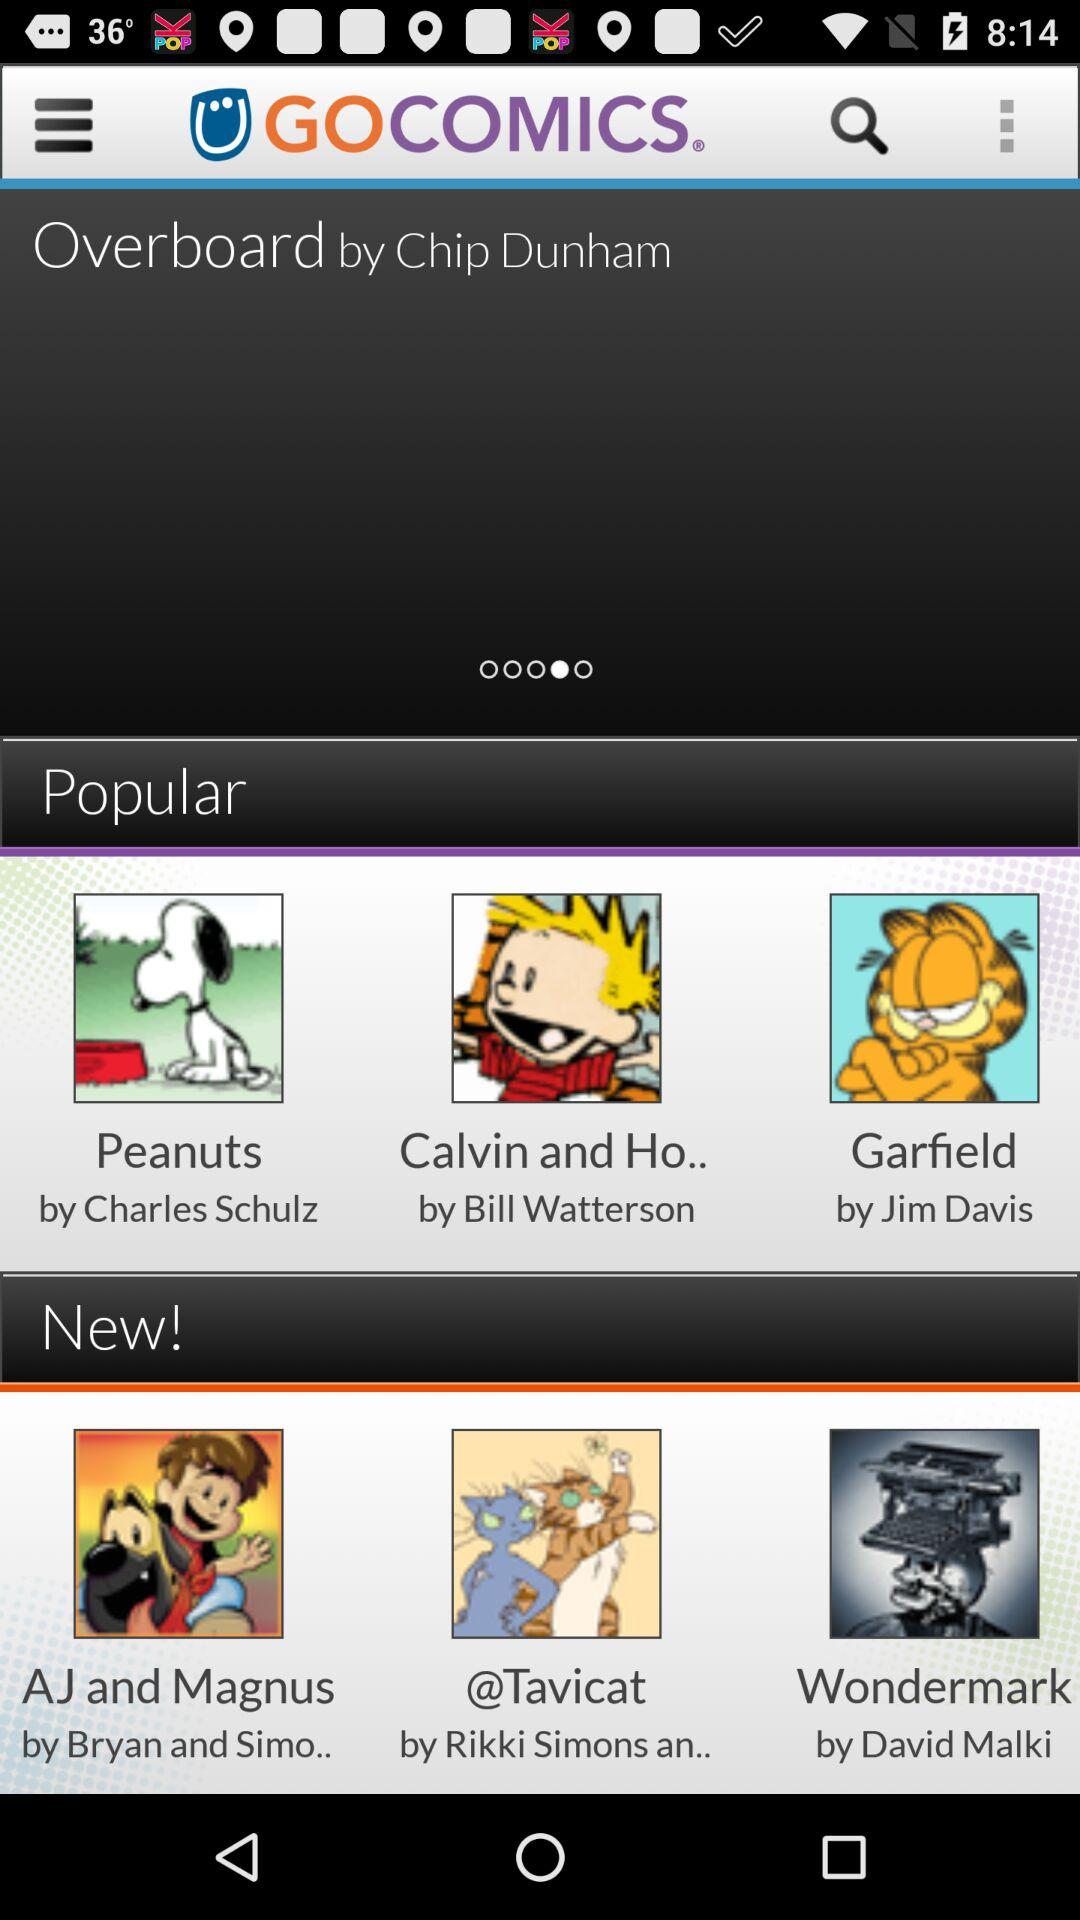What is the application name? The application name is "GOCOMICS". 